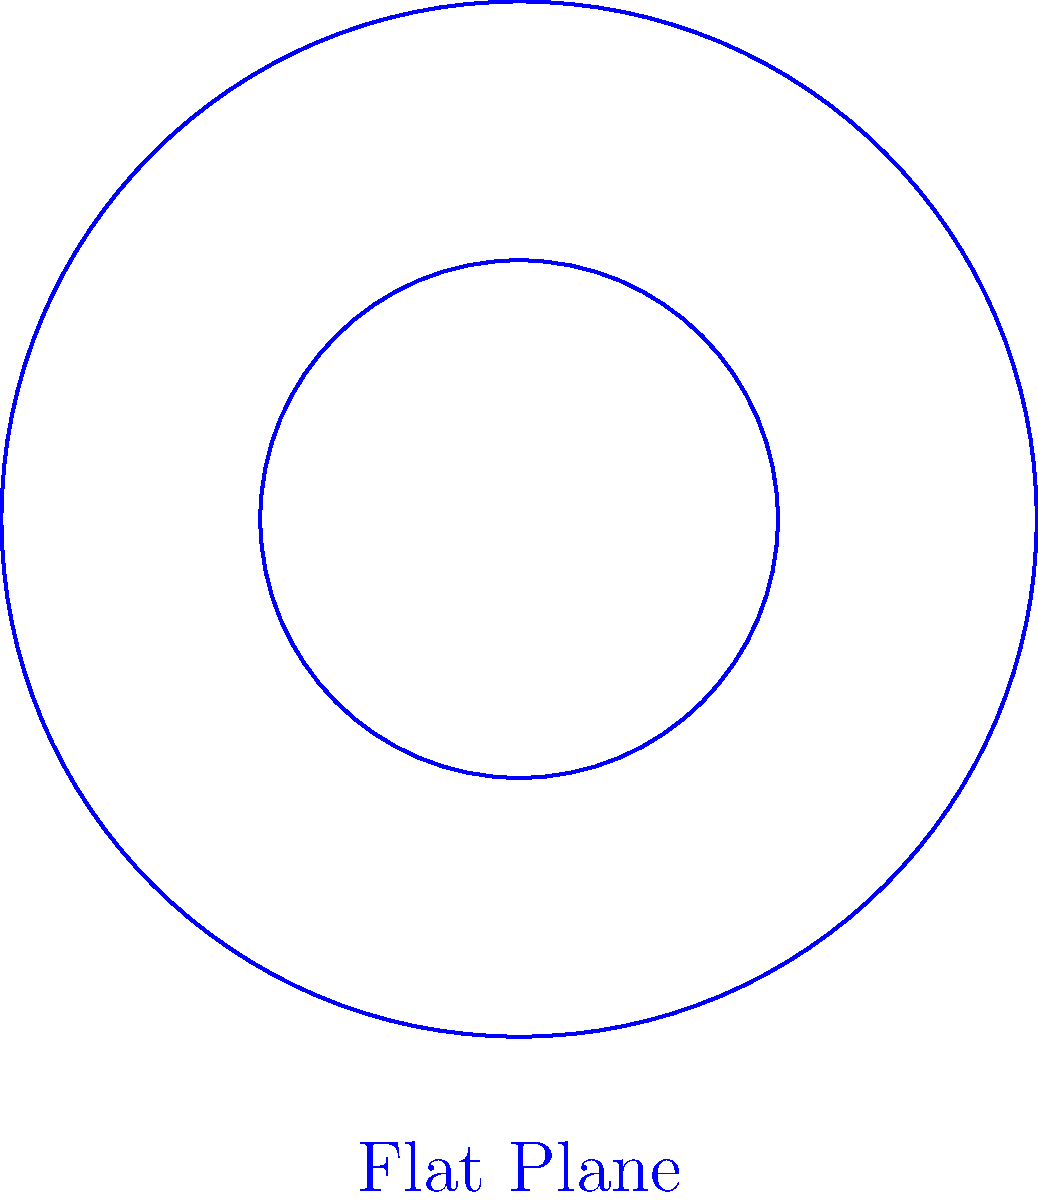In the context of workplace safety regulations, consider the diagram showing circles on a flat plane and a curved surface. If these representations were used to model safe working areas, how would the ratio of the larger circle's area to the smaller circle's area differ between the flat plane and the curved surface? Explain the implications for creating equitable safety zones in various work environments. Let's approach this step-by-step:

1. On a flat plane (Euclidean geometry):
   - Area of a circle: $A = \pi r^2$
   - Ratio of areas: $\frac{A_2}{A_1} = \frac{\pi r_2^2}{\pi r_1^2} = \frac{r_2^2}{r_1^2}$
   - If $r_2 = 2r_1$, then $\frac{A_2}{A_1} = \frac{(2r_1)^2}{r_1^2} = 4$

2. On a curved surface (Non-Euclidean geometry):
   - Area of a circle on a sphere: $A = 2\pi R^2(1-\cos(\frac{r}{R}))$, where $R$ is the sphere's radius
   - Ratio of areas: $\frac{A_2}{A_1} = \frac{1-\cos(\frac{r_2}{R})}{1-\cos(\frac{r_1}{R})}$
   - This ratio is always less than 4 when $r_2 = 2r_1$

3. Implications for workplace safety:
   - On a flat surface, doubling the radius quadruples the safe working area
   - On a curved surface, doubling the radius increases the area by less than four times
   - This means that in curved environments (e.g., spherical tanks, domed structures), using flat plane calculations would overestimate the safe working area

4. Equity considerations:
   - Standardized safety regulations based on flat plane geometry may not provide equal protection in curved work environments
   - Workers in curved spaces might have less safe area than anticipated, potentially increasing risk

5. Recommendations:
   - Develop specific safety guidelines for non-Euclidean work environments
   - Use appropriate geometric models when calculating safe working areas in curved spaces
   - Ensure workers in all environments have equitable protection, adjusting area calculations as needed
Answer: The area ratio is 4:1 on a flat plane but less than 4:1 on a curved surface, necessitating adjusted safety regulations for curved work environments to ensure equitable protection. 